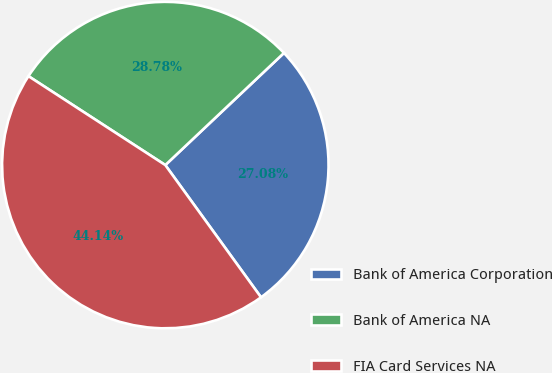Convert chart to OTSL. <chart><loc_0><loc_0><loc_500><loc_500><pie_chart><fcel>Bank of America Corporation<fcel>Bank of America NA<fcel>FIA Card Services NA<nl><fcel>27.08%<fcel>28.78%<fcel>44.14%<nl></chart> 